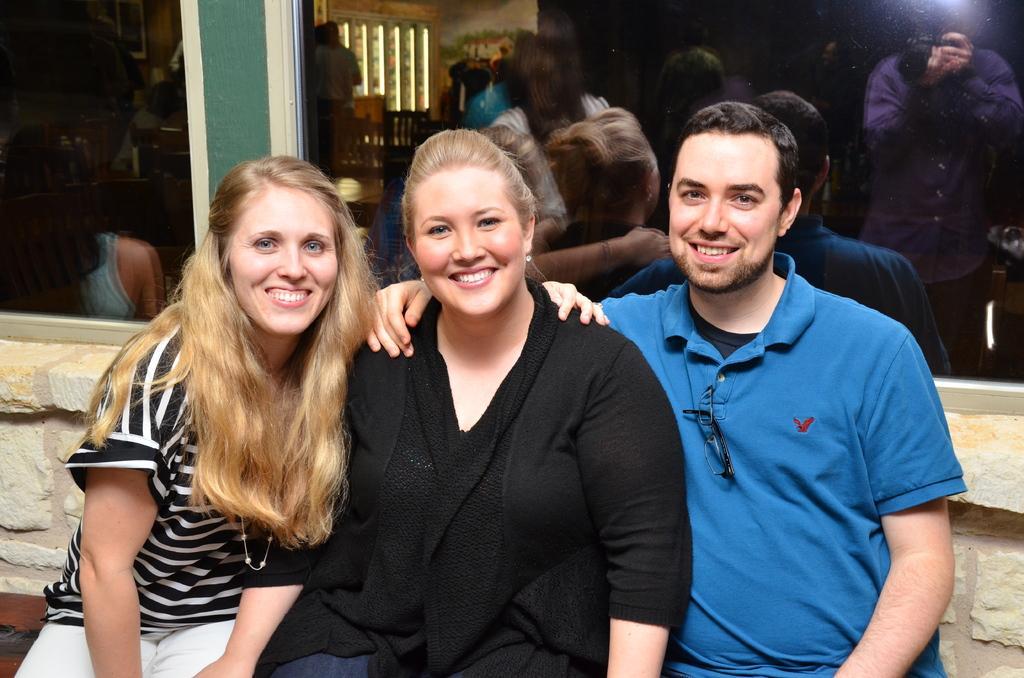Please provide a concise description of this image. In this picture we can see two women sitting in the front, smiling and giving a pose to the camera. Beside there is a man wearing blue t-shirt and smiling. Behind there is a black color glass and we can see some personal reflections. 